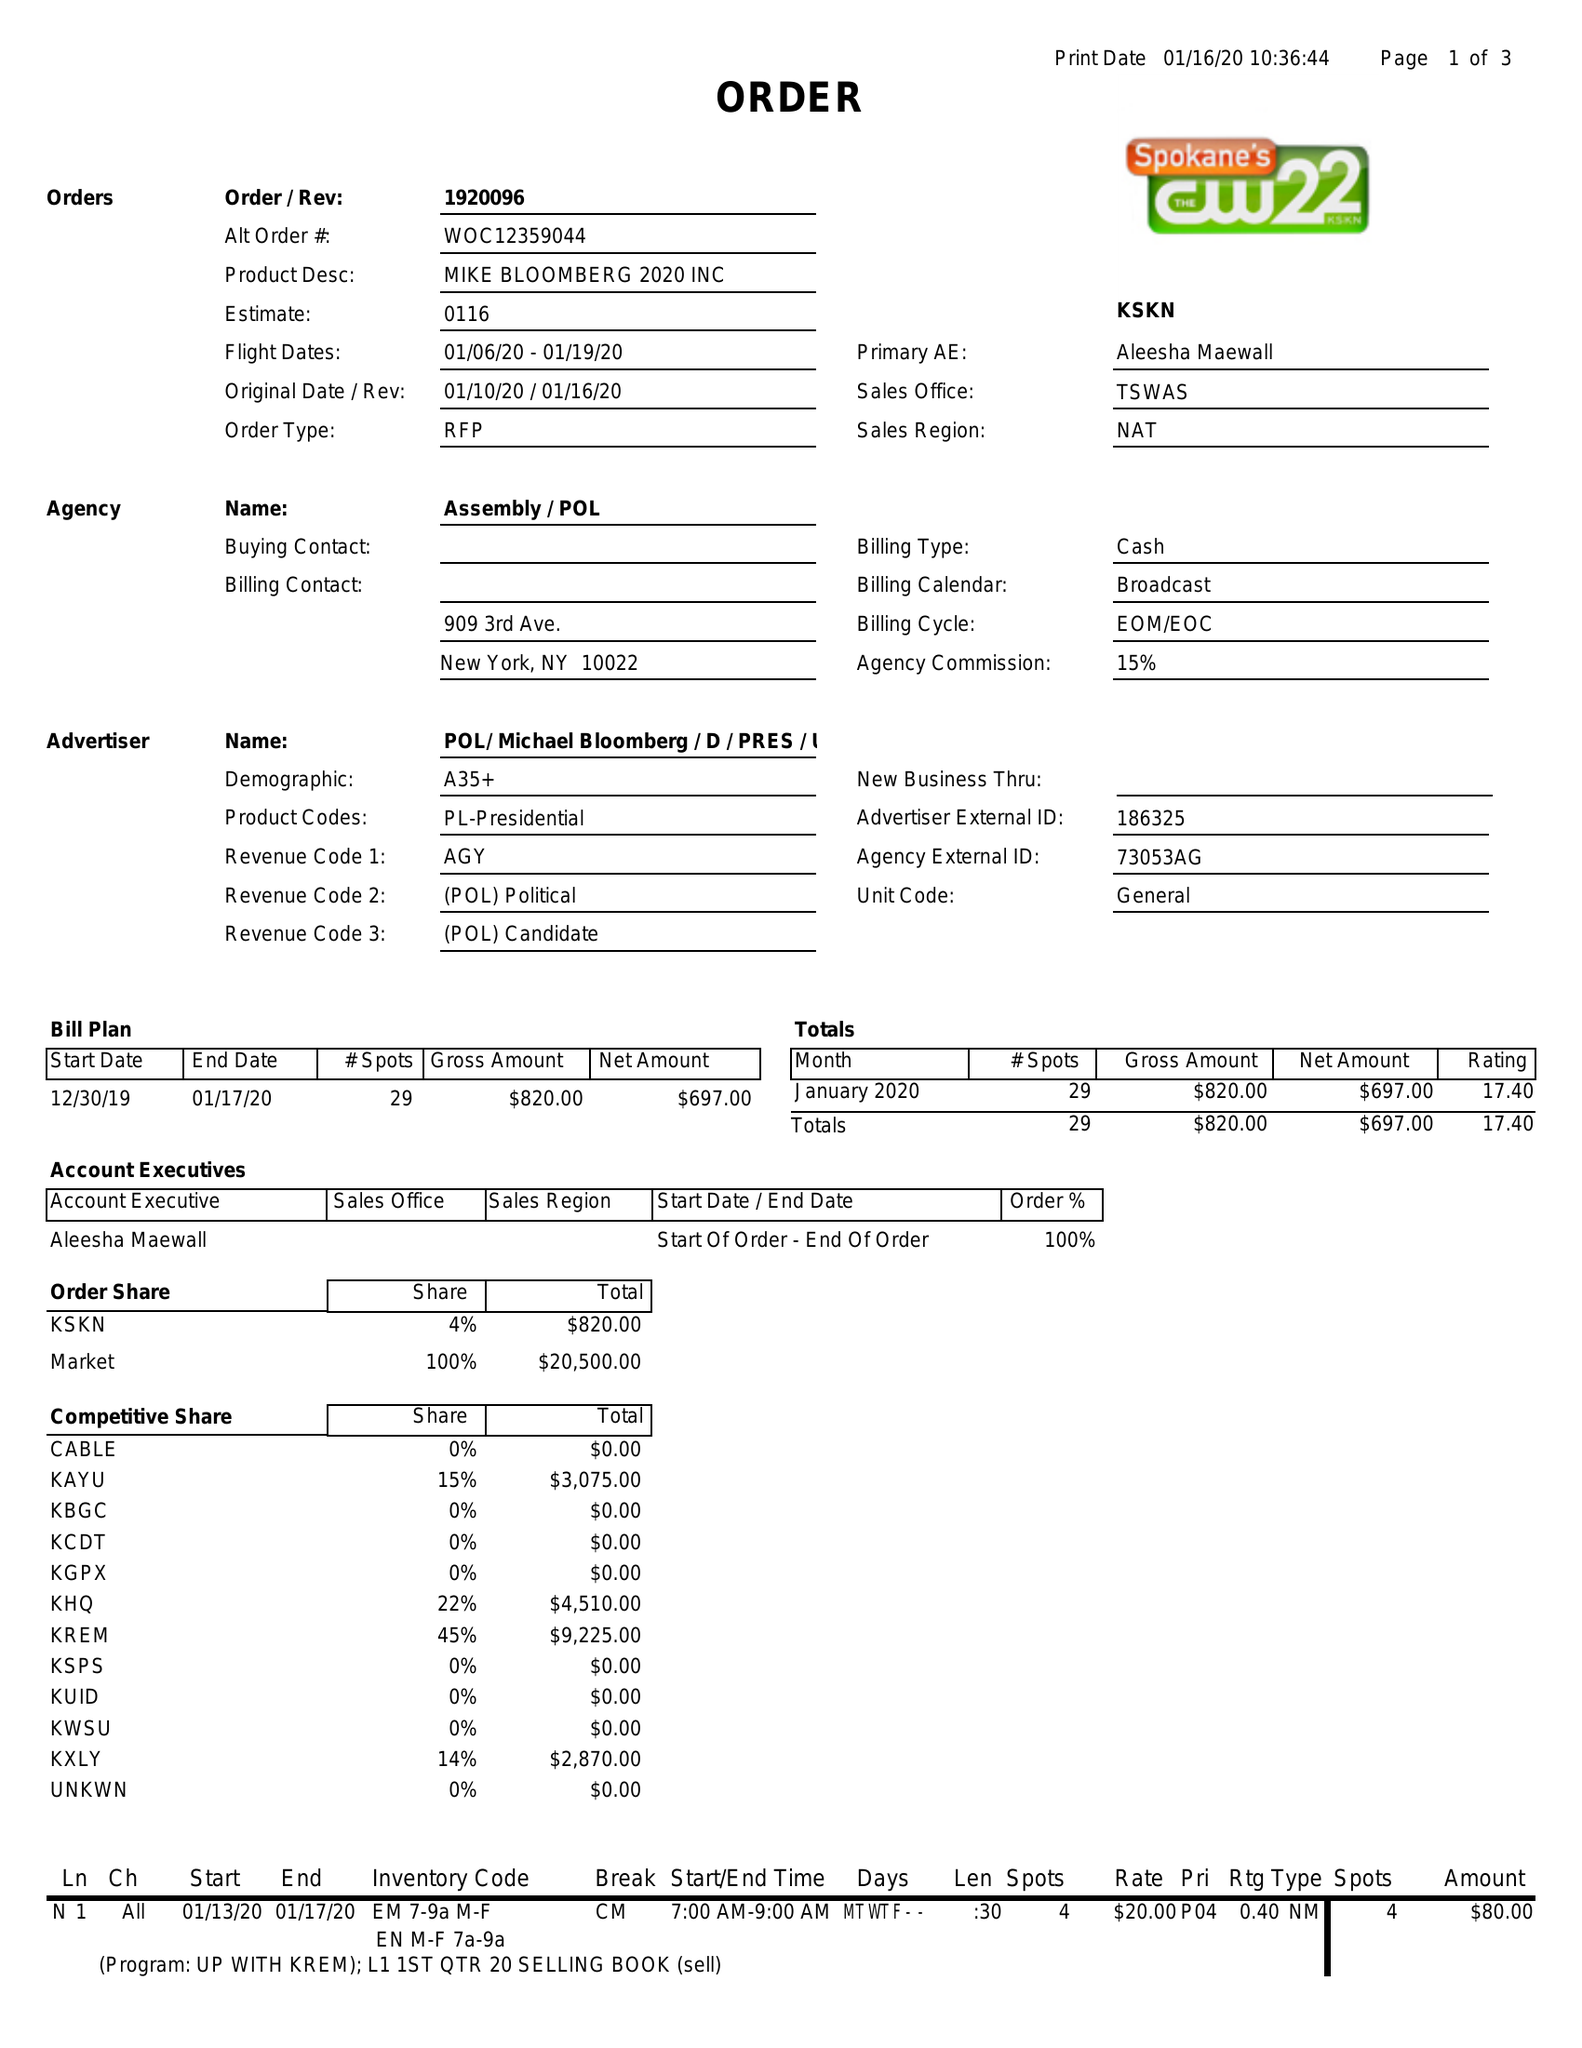What is the value for the contract_num?
Answer the question using a single word or phrase. 1920096 